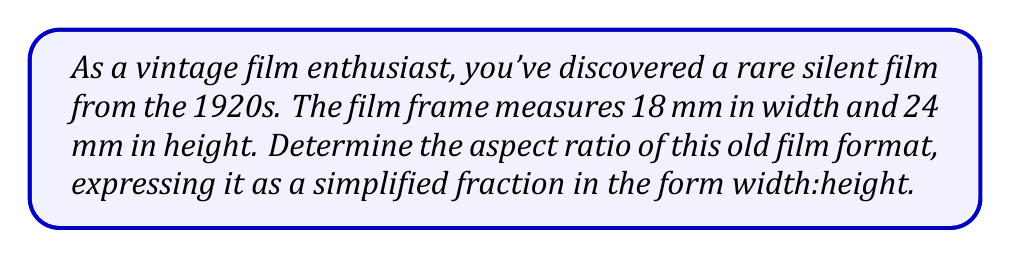Teach me how to tackle this problem. To determine the aspect ratio of the film, we need to follow these steps:

1. Identify the width and height measurements:
   Width = 18 mm
   Height = 24 mm

2. Express the ratio of width to height:
   $\frac{\text{Width}}{\text{Height}} = \frac{18 \text{ mm}}{24 \text{ mm}}$

3. Simplify the fraction:
   To simplify, we need to find the greatest common divisor (GCD) of 18 and 24.
   
   Factors of 18: 1, 2, 3, 6, 9, 18
   Factors of 24: 1, 2, 3, 4, 6, 8, 12, 24
   
   The greatest common divisor is 6.

4. Divide both the numerator and denominator by the GCD:
   $$\frac{18 \div 6}{24 \div 6} = \frac{3}{4}$$

5. Express the ratio in the form width:height:
   3:4

Therefore, the aspect ratio of this old film format is 3:4.
Answer: 3:4 